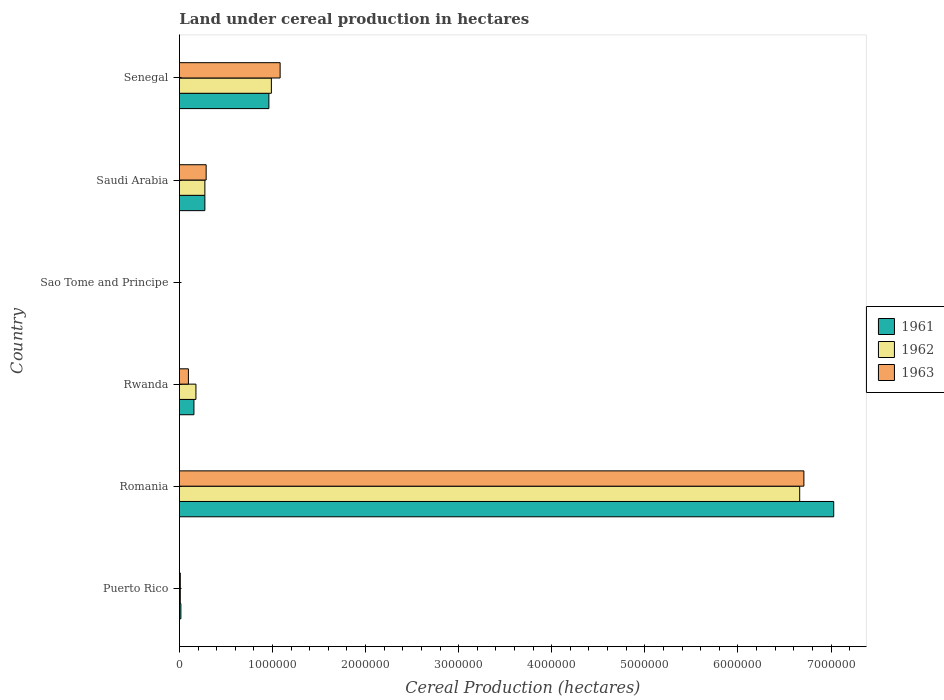How many different coloured bars are there?
Your answer should be very brief. 3. Are the number of bars per tick equal to the number of legend labels?
Your response must be concise. Yes. What is the label of the 4th group of bars from the top?
Your response must be concise. Rwanda. What is the land under cereal production in 1963 in Sao Tome and Principe?
Make the answer very short. 270. Across all countries, what is the maximum land under cereal production in 1963?
Offer a very short reply. 6.71e+06. Across all countries, what is the minimum land under cereal production in 1962?
Give a very brief answer. 270. In which country was the land under cereal production in 1961 maximum?
Your response must be concise. Romania. In which country was the land under cereal production in 1962 minimum?
Make the answer very short. Sao Tome and Principe. What is the total land under cereal production in 1962 in the graph?
Provide a short and direct response. 8.11e+06. What is the difference between the land under cereal production in 1963 in Puerto Rico and that in Romania?
Ensure brevity in your answer.  -6.70e+06. What is the difference between the land under cereal production in 1961 in Saudi Arabia and the land under cereal production in 1963 in Sao Tome and Principe?
Keep it short and to the point. 2.73e+05. What is the average land under cereal production in 1962 per country?
Offer a terse response. 1.35e+06. What is the ratio of the land under cereal production in 1962 in Puerto Rico to that in Senegal?
Make the answer very short. 0.01. Is the land under cereal production in 1962 in Sao Tome and Principe less than that in Senegal?
Provide a short and direct response. Yes. What is the difference between the highest and the second highest land under cereal production in 1963?
Keep it short and to the point. 5.63e+06. What is the difference between the highest and the lowest land under cereal production in 1961?
Give a very brief answer. 7.03e+06. In how many countries, is the land under cereal production in 1963 greater than the average land under cereal production in 1963 taken over all countries?
Offer a very short reply. 1. Is the sum of the land under cereal production in 1963 in Puerto Rico and Sao Tome and Principe greater than the maximum land under cereal production in 1961 across all countries?
Keep it short and to the point. No. What does the 2nd bar from the bottom in Saudi Arabia represents?
Keep it short and to the point. 1962. Is it the case that in every country, the sum of the land under cereal production in 1962 and land under cereal production in 1961 is greater than the land under cereal production in 1963?
Give a very brief answer. Yes. How many bars are there?
Make the answer very short. 18. Are all the bars in the graph horizontal?
Make the answer very short. Yes. Does the graph contain grids?
Keep it short and to the point. No. Where does the legend appear in the graph?
Keep it short and to the point. Center right. How many legend labels are there?
Provide a succinct answer. 3. What is the title of the graph?
Ensure brevity in your answer.  Land under cereal production in hectares. Does "1981" appear as one of the legend labels in the graph?
Your response must be concise. No. What is the label or title of the X-axis?
Offer a very short reply. Cereal Production (hectares). What is the label or title of the Y-axis?
Give a very brief answer. Country. What is the Cereal Production (hectares) in 1961 in Puerto Rico?
Offer a very short reply. 1.59e+04. What is the Cereal Production (hectares) of 1962 in Puerto Rico?
Your answer should be very brief. 9489. What is the Cereal Production (hectares) of 1963 in Puerto Rico?
Offer a terse response. 9519. What is the Cereal Production (hectares) of 1961 in Romania?
Make the answer very short. 7.03e+06. What is the Cereal Production (hectares) in 1962 in Romania?
Offer a very short reply. 6.66e+06. What is the Cereal Production (hectares) of 1963 in Romania?
Provide a short and direct response. 6.71e+06. What is the Cereal Production (hectares) in 1961 in Rwanda?
Your answer should be compact. 1.56e+05. What is the Cereal Production (hectares) in 1962 in Rwanda?
Give a very brief answer. 1.78e+05. What is the Cereal Production (hectares) of 1963 in Rwanda?
Ensure brevity in your answer.  9.66e+04. What is the Cereal Production (hectares) in 1961 in Sao Tome and Principe?
Provide a succinct answer. 270. What is the Cereal Production (hectares) of 1962 in Sao Tome and Principe?
Offer a very short reply. 270. What is the Cereal Production (hectares) in 1963 in Sao Tome and Principe?
Provide a short and direct response. 270. What is the Cereal Production (hectares) of 1961 in Saudi Arabia?
Give a very brief answer. 2.74e+05. What is the Cereal Production (hectares) in 1962 in Saudi Arabia?
Keep it short and to the point. 2.74e+05. What is the Cereal Production (hectares) in 1963 in Saudi Arabia?
Make the answer very short. 2.87e+05. What is the Cereal Production (hectares) of 1961 in Senegal?
Offer a very short reply. 9.61e+05. What is the Cereal Production (hectares) of 1962 in Senegal?
Give a very brief answer. 9.88e+05. What is the Cereal Production (hectares) of 1963 in Senegal?
Make the answer very short. 1.08e+06. Across all countries, what is the maximum Cereal Production (hectares) of 1961?
Offer a terse response. 7.03e+06. Across all countries, what is the maximum Cereal Production (hectares) in 1962?
Give a very brief answer. 6.66e+06. Across all countries, what is the maximum Cereal Production (hectares) of 1963?
Give a very brief answer. 6.71e+06. Across all countries, what is the minimum Cereal Production (hectares) in 1961?
Your answer should be very brief. 270. Across all countries, what is the minimum Cereal Production (hectares) in 1962?
Provide a succinct answer. 270. Across all countries, what is the minimum Cereal Production (hectares) of 1963?
Your response must be concise. 270. What is the total Cereal Production (hectares) in 1961 in the graph?
Your answer should be compact. 8.44e+06. What is the total Cereal Production (hectares) of 1962 in the graph?
Make the answer very short. 8.11e+06. What is the total Cereal Production (hectares) in 1963 in the graph?
Your answer should be compact. 8.18e+06. What is the difference between the Cereal Production (hectares) in 1961 in Puerto Rico and that in Romania?
Offer a terse response. -7.01e+06. What is the difference between the Cereal Production (hectares) in 1962 in Puerto Rico and that in Romania?
Give a very brief answer. -6.65e+06. What is the difference between the Cereal Production (hectares) in 1963 in Puerto Rico and that in Romania?
Give a very brief answer. -6.70e+06. What is the difference between the Cereal Production (hectares) in 1961 in Puerto Rico and that in Rwanda?
Ensure brevity in your answer.  -1.40e+05. What is the difference between the Cereal Production (hectares) of 1962 in Puerto Rico and that in Rwanda?
Make the answer very short. -1.68e+05. What is the difference between the Cereal Production (hectares) of 1963 in Puerto Rico and that in Rwanda?
Give a very brief answer. -8.71e+04. What is the difference between the Cereal Production (hectares) of 1961 in Puerto Rico and that in Sao Tome and Principe?
Keep it short and to the point. 1.56e+04. What is the difference between the Cereal Production (hectares) in 1962 in Puerto Rico and that in Sao Tome and Principe?
Your response must be concise. 9219. What is the difference between the Cereal Production (hectares) in 1963 in Puerto Rico and that in Sao Tome and Principe?
Give a very brief answer. 9249. What is the difference between the Cereal Production (hectares) in 1961 in Puerto Rico and that in Saudi Arabia?
Give a very brief answer. -2.58e+05. What is the difference between the Cereal Production (hectares) in 1962 in Puerto Rico and that in Saudi Arabia?
Give a very brief answer. -2.64e+05. What is the difference between the Cereal Production (hectares) of 1963 in Puerto Rico and that in Saudi Arabia?
Ensure brevity in your answer.  -2.78e+05. What is the difference between the Cereal Production (hectares) of 1961 in Puerto Rico and that in Senegal?
Your response must be concise. -9.45e+05. What is the difference between the Cereal Production (hectares) in 1962 in Puerto Rico and that in Senegal?
Make the answer very short. -9.79e+05. What is the difference between the Cereal Production (hectares) of 1963 in Puerto Rico and that in Senegal?
Your response must be concise. -1.07e+06. What is the difference between the Cereal Production (hectares) of 1961 in Romania and that in Rwanda?
Ensure brevity in your answer.  6.87e+06. What is the difference between the Cereal Production (hectares) of 1962 in Romania and that in Rwanda?
Your answer should be very brief. 6.49e+06. What is the difference between the Cereal Production (hectares) of 1963 in Romania and that in Rwanda?
Your response must be concise. 6.61e+06. What is the difference between the Cereal Production (hectares) of 1961 in Romania and that in Sao Tome and Principe?
Ensure brevity in your answer.  7.03e+06. What is the difference between the Cereal Production (hectares) in 1962 in Romania and that in Sao Tome and Principe?
Your answer should be very brief. 6.66e+06. What is the difference between the Cereal Production (hectares) of 1963 in Romania and that in Sao Tome and Principe?
Provide a short and direct response. 6.71e+06. What is the difference between the Cereal Production (hectares) of 1961 in Romania and that in Saudi Arabia?
Ensure brevity in your answer.  6.76e+06. What is the difference between the Cereal Production (hectares) of 1962 in Romania and that in Saudi Arabia?
Make the answer very short. 6.39e+06. What is the difference between the Cereal Production (hectares) in 1963 in Romania and that in Saudi Arabia?
Provide a short and direct response. 6.42e+06. What is the difference between the Cereal Production (hectares) of 1961 in Romania and that in Senegal?
Your answer should be very brief. 6.07e+06. What is the difference between the Cereal Production (hectares) of 1962 in Romania and that in Senegal?
Your response must be concise. 5.68e+06. What is the difference between the Cereal Production (hectares) of 1963 in Romania and that in Senegal?
Provide a short and direct response. 5.63e+06. What is the difference between the Cereal Production (hectares) of 1961 in Rwanda and that in Sao Tome and Principe?
Your answer should be compact. 1.56e+05. What is the difference between the Cereal Production (hectares) in 1962 in Rwanda and that in Sao Tome and Principe?
Keep it short and to the point. 1.77e+05. What is the difference between the Cereal Production (hectares) of 1963 in Rwanda and that in Sao Tome and Principe?
Offer a very short reply. 9.64e+04. What is the difference between the Cereal Production (hectares) in 1961 in Rwanda and that in Saudi Arabia?
Your response must be concise. -1.17e+05. What is the difference between the Cereal Production (hectares) in 1962 in Rwanda and that in Saudi Arabia?
Your response must be concise. -9.61e+04. What is the difference between the Cereal Production (hectares) in 1963 in Rwanda and that in Saudi Arabia?
Provide a succinct answer. -1.91e+05. What is the difference between the Cereal Production (hectares) of 1961 in Rwanda and that in Senegal?
Provide a succinct answer. -8.05e+05. What is the difference between the Cereal Production (hectares) in 1962 in Rwanda and that in Senegal?
Offer a very short reply. -8.10e+05. What is the difference between the Cereal Production (hectares) of 1963 in Rwanda and that in Senegal?
Keep it short and to the point. -9.85e+05. What is the difference between the Cereal Production (hectares) of 1961 in Sao Tome and Principe and that in Saudi Arabia?
Your answer should be very brief. -2.73e+05. What is the difference between the Cereal Production (hectares) of 1962 in Sao Tome and Principe and that in Saudi Arabia?
Make the answer very short. -2.73e+05. What is the difference between the Cereal Production (hectares) in 1963 in Sao Tome and Principe and that in Saudi Arabia?
Ensure brevity in your answer.  -2.87e+05. What is the difference between the Cereal Production (hectares) in 1961 in Sao Tome and Principe and that in Senegal?
Offer a very short reply. -9.61e+05. What is the difference between the Cereal Production (hectares) in 1962 in Sao Tome and Principe and that in Senegal?
Offer a terse response. -9.88e+05. What is the difference between the Cereal Production (hectares) in 1963 in Sao Tome and Principe and that in Senegal?
Ensure brevity in your answer.  -1.08e+06. What is the difference between the Cereal Production (hectares) of 1961 in Saudi Arabia and that in Senegal?
Provide a succinct answer. -6.88e+05. What is the difference between the Cereal Production (hectares) of 1962 in Saudi Arabia and that in Senegal?
Keep it short and to the point. -7.14e+05. What is the difference between the Cereal Production (hectares) in 1963 in Saudi Arabia and that in Senegal?
Offer a terse response. -7.95e+05. What is the difference between the Cereal Production (hectares) in 1961 in Puerto Rico and the Cereal Production (hectares) in 1962 in Romania?
Ensure brevity in your answer.  -6.65e+06. What is the difference between the Cereal Production (hectares) of 1961 in Puerto Rico and the Cereal Production (hectares) of 1963 in Romania?
Give a very brief answer. -6.69e+06. What is the difference between the Cereal Production (hectares) in 1962 in Puerto Rico and the Cereal Production (hectares) in 1963 in Romania?
Ensure brevity in your answer.  -6.70e+06. What is the difference between the Cereal Production (hectares) of 1961 in Puerto Rico and the Cereal Production (hectares) of 1962 in Rwanda?
Ensure brevity in your answer.  -1.62e+05. What is the difference between the Cereal Production (hectares) in 1961 in Puerto Rico and the Cereal Production (hectares) in 1963 in Rwanda?
Keep it short and to the point. -8.08e+04. What is the difference between the Cereal Production (hectares) of 1962 in Puerto Rico and the Cereal Production (hectares) of 1963 in Rwanda?
Ensure brevity in your answer.  -8.72e+04. What is the difference between the Cereal Production (hectares) in 1961 in Puerto Rico and the Cereal Production (hectares) in 1962 in Sao Tome and Principe?
Offer a very short reply. 1.56e+04. What is the difference between the Cereal Production (hectares) in 1961 in Puerto Rico and the Cereal Production (hectares) in 1963 in Sao Tome and Principe?
Offer a terse response. 1.56e+04. What is the difference between the Cereal Production (hectares) of 1962 in Puerto Rico and the Cereal Production (hectares) of 1963 in Sao Tome and Principe?
Your response must be concise. 9219. What is the difference between the Cereal Production (hectares) in 1961 in Puerto Rico and the Cereal Production (hectares) in 1962 in Saudi Arabia?
Ensure brevity in your answer.  -2.58e+05. What is the difference between the Cereal Production (hectares) in 1961 in Puerto Rico and the Cereal Production (hectares) in 1963 in Saudi Arabia?
Give a very brief answer. -2.71e+05. What is the difference between the Cereal Production (hectares) in 1962 in Puerto Rico and the Cereal Production (hectares) in 1963 in Saudi Arabia?
Provide a short and direct response. -2.78e+05. What is the difference between the Cereal Production (hectares) in 1961 in Puerto Rico and the Cereal Production (hectares) in 1962 in Senegal?
Offer a terse response. -9.72e+05. What is the difference between the Cereal Production (hectares) in 1961 in Puerto Rico and the Cereal Production (hectares) in 1963 in Senegal?
Provide a short and direct response. -1.07e+06. What is the difference between the Cereal Production (hectares) of 1962 in Puerto Rico and the Cereal Production (hectares) of 1963 in Senegal?
Your answer should be very brief. -1.07e+06. What is the difference between the Cereal Production (hectares) of 1961 in Romania and the Cereal Production (hectares) of 1962 in Rwanda?
Provide a succinct answer. 6.85e+06. What is the difference between the Cereal Production (hectares) in 1961 in Romania and the Cereal Production (hectares) in 1963 in Rwanda?
Ensure brevity in your answer.  6.93e+06. What is the difference between the Cereal Production (hectares) in 1962 in Romania and the Cereal Production (hectares) in 1963 in Rwanda?
Your response must be concise. 6.57e+06. What is the difference between the Cereal Production (hectares) in 1961 in Romania and the Cereal Production (hectares) in 1962 in Sao Tome and Principe?
Ensure brevity in your answer.  7.03e+06. What is the difference between the Cereal Production (hectares) in 1961 in Romania and the Cereal Production (hectares) in 1963 in Sao Tome and Principe?
Give a very brief answer. 7.03e+06. What is the difference between the Cereal Production (hectares) of 1962 in Romania and the Cereal Production (hectares) of 1963 in Sao Tome and Principe?
Make the answer very short. 6.66e+06. What is the difference between the Cereal Production (hectares) in 1961 in Romania and the Cereal Production (hectares) in 1962 in Saudi Arabia?
Ensure brevity in your answer.  6.76e+06. What is the difference between the Cereal Production (hectares) of 1961 in Romania and the Cereal Production (hectares) of 1963 in Saudi Arabia?
Offer a very short reply. 6.74e+06. What is the difference between the Cereal Production (hectares) in 1962 in Romania and the Cereal Production (hectares) in 1963 in Saudi Arabia?
Provide a succinct answer. 6.38e+06. What is the difference between the Cereal Production (hectares) of 1961 in Romania and the Cereal Production (hectares) of 1962 in Senegal?
Provide a succinct answer. 6.04e+06. What is the difference between the Cereal Production (hectares) in 1961 in Romania and the Cereal Production (hectares) in 1963 in Senegal?
Your answer should be very brief. 5.95e+06. What is the difference between the Cereal Production (hectares) in 1962 in Romania and the Cereal Production (hectares) in 1963 in Senegal?
Provide a succinct answer. 5.58e+06. What is the difference between the Cereal Production (hectares) of 1961 in Rwanda and the Cereal Production (hectares) of 1962 in Sao Tome and Principe?
Ensure brevity in your answer.  1.56e+05. What is the difference between the Cereal Production (hectares) of 1961 in Rwanda and the Cereal Production (hectares) of 1963 in Sao Tome and Principe?
Give a very brief answer. 1.56e+05. What is the difference between the Cereal Production (hectares) of 1962 in Rwanda and the Cereal Production (hectares) of 1963 in Sao Tome and Principe?
Keep it short and to the point. 1.77e+05. What is the difference between the Cereal Production (hectares) in 1961 in Rwanda and the Cereal Production (hectares) in 1962 in Saudi Arabia?
Your answer should be compact. -1.18e+05. What is the difference between the Cereal Production (hectares) of 1961 in Rwanda and the Cereal Production (hectares) of 1963 in Saudi Arabia?
Keep it short and to the point. -1.31e+05. What is the difference between the Cereal Production (hectares) of 1962 in Rwanda and the Cereal Production (hectares) of 1963 in Saudi Arabia?
Keep it short and to the point. -1.10e+05. What is the difference between the Cereal Production (hectares) in 1961 in Rwanda and the Cereal Production (hectares) in 1962 in Senegal?
Give a very brief answer. -8.32e+05. What is the difference between the Cereal Production (hectares) in 1961 in Rwanda and the Cereal Production (hectares) in 1963 in Senegal?
Offer a very short reply. -9.26e+05. What is the difference between the Cereal Production (hectares) of 1962 in Rwanda and the Cereal Production (hectares) of 1963 in Senegal?
Offer a very short reply. -9.04e+05. What is the difference between the Cereal Production (hectares) of 1961 in Sao Tome and Principe and the Cereal Production (hectares) of 1962 in Saudi Arabia?
Your answer should be very brief. -2.73e+05. What is the difference between the Cereal Production (hectares) of 1961 in Sao Tome and Principe and the Cereal Production (hectares) of 1963 in Saudi Arabia?
Give a very brief answer. -2.87e+05. What is the difference between the Cereal Production (hectares) in 1962 in Sao Tome and Principe and the Cereal Production (hectares) in 1963 in Saudi Arabia?
Give a very brief answer. -2.87e+05. What is the difference between the Cereal Production (hectares) in 1961 in Sao Tome and Principe and the Cereal Production (hectares) in 1962 in Senegal?
Make the answer very short. -9.88e+05. What is the difference between the Cereal Production (hectares) in 1961 in Sao Tome and Principe and the Cereal Production (hectares) in 1963 in Senegal?
Your answer should be compact. -1.08e+06. What is the difference between the Cereal Production (hectares) of 1962 in Sao Tome and Principe and the Cereal Production (hectares) of 1963 in Senegal?
Your answer should be very brief. -1.08e+06. What is the difference between the Cereal Production (hectares) in 1961 in Saudi Arabia and the Cereal Production (hectares) in 1962 in Senegal?
Your response must be concise. -7.14e+05. What is the difference between the Cereal Production (hectares) of 1961 in Saudi Arabia and the Cereal Production (hectares) of 1963 in Senegal?
Keep it short and to the point. -8.08e+05. What is the difference between the Cereal Production (hectares) in 1962 in Saudi Arabia and the Cereal Production (hectares) in 1963 in Senegal?
Provide a succinct answer. -8.08e+05. What is the average Cereal Production (hectares) of 1961 per country?
Give a very brief answer. 1.41e+06. What is the average Cereal Production (hectares) in 1962 per country?
Provide a short and direct response. 1.35e+06. What is the average Cereal Production (hectares) of 1963 per country?
Provide a short and direct response. 1.36e+06. What is the difference between the Cereal Production (hectares) of 1961 and Cereal Production (hectares) of 1962 in Puerto Rico?
Provide a short and direct response. 6383. What is the difference between the Cereal Production (hectares) in 1961 and Cereal Production (hectares) in 1963 in Puerto Rico?
Provide a succinct answer. 6353. What is the difference between the Cereal Production (hectares) in 1961 and Cereal Production (hectares) in 1962 in Romania?
Provide a short and direct response. 3.65e+05. What is the difference between the Cereal Production (hectares) in 1961 and Cereal Production (hectares) in 1963 in Romania?
Give a very brief answer. 3.20e+05. What is the difference between the Cereal Production (hectares) in 1962 and Cereal Production (hectares) in 1963 in Romania?
Make the answer very short. -4.51e+04. What is the difference between the Cereal Production (hectares) of 1961 and Cereal Production (hectares) of 1962 in Rwanda?
Ensure brevity in your answer.  -2.15e+04. What is the difference between the Cereal Production (hectares) of 1961 and Cereal Production (hectares) of 1963 in Rwanda?
Ensure brevity in your answer.  5.94e+04. What is the difference between the Cereal Production (hectares) in 1962 and Cereal Production (hectares) in 1963 in Rwanda?
Provide a short and direct response. 8.09e+04. What is the difference between the Cereal Production (hectares) in 1961 and Cereal Production (hectares) in 1962 in Sao Tome and Principe?
Your answer should be compact. 0. What is the difference between the Cereal Production (hectares) in 1961 and Cereal Production (hectares) in 1963 in Sao Tome and Principe?
Your answer should be very brief. 0. What is the difference between the Cereal Production (hectares) in 1962 and Cereal Production (hectares) in 1963 in Sao Tome and Principe?
Your response must be concise. 0. What is the difference between the Cereal Production (hectares) of 1961 and Cereal Production (hectares) of 1962 in Saudi Arabia?
Provide a succinct answer. -100. What is the difference between the Cereal Production (hectares) of 1961 and Cereal Production (hectares) of 1963 in Saudi Arabia?
Ensure brevity in your answer.  -1.38e+04. What is the difference between the Cereal Production (hectares) of 1962 and Cereal Production (hectares) of 1963 in Saudi Arabia?
Your answer should be very brief. -1.37e+04. What is the difference between the Cereal Production (hectares) in 1961 and Cereal Production (hectares) in 1962 in Senegal?
Your response must be concise. -2.68e+04. What is the difference between the Cereal Production (hectares) of 1961 and Cereal Production (hectares) of 1963 in Senegal?
Offer a very short reply. -1.21e+05. What is the difference between the Cereal Production (hectares) in 1962 and Cereal Production (hectares) in 1963 in Senegal?
Your response must be concise. -9.40e+04. What is the ratio of the Cereal Production (hectares) of 1961 in Puerto Rico to that in Romania?
Give a very brief answer. 0. What is the ratio of the Cereal Production (hectares) of 1962 in Puerto Rico to that in Romania?
Your answer should be very brief. 0. What is the ratio of the Cereal Production (hectares) of 1963 in Puerto Rico to that in Romania?
Your response must be concise. 0. What is the ratio of the Cereal Production (hectares) in 1961 in Puerto Rico to that in Rwanda?
Offer a very short reply. 0.1. What is the ratio of the Cereal Production (hectares) of 1962 in Puerto Rico to that in Rwanda?
Make the answer very short. 0.05. What is the ratio of the Cereal Production (hectares) in 1963 in Puerto Rico to that in Rwanda?
Offer a very short reply. 0.1. What is the ratio of the Cereal Production (hectares) in 1961 in Puerto Rico to that in Sao Tome and Principe?
Your response must be concise. 58.79. What is the ratio of the Cereal Production (hectares) of 1962 in Puerto Rico to that in Sao Tome and Principe?
Make the answer very short. 35.14. What is the ratio of the Cereal Production (hectares) of 1963 in Puerto Rico to that in Sao Tome and Principe?
Your answer should be compact. 35.26. What is the ratio of the Cereal Production (hectares) of 1961 in Puerto Rico to that in Saudi Arabia?
Give a very brief answer. 0.06. What is the ratio of the Cereal Production (hectares) of 1962 in Puerto Rico to that in Saudi Arabia?
Your answer should be compact. 0.03. What is the ratio of the Cereal Production (hectares) in 1963 in Puerto Rico to that in Saudi Arabia?
Give a very brief answer. 0.03. What is the ratio of the Cereal Production (hectares) of 1961 in Puerto Rico to that in Senegal?
Ensure brevity in your answer.  0.02. What is the ratio of the Cereal Production (hectares) in 1962 in Puerto Rico to that in Senegal?
Provide a short and direct response. 0.01. What is the ratio of the Cereal Production (hectares) in 1963 in Puerto Rico to that in Senegal?
Offer a terse response. 0.01. What is the ratio of the Cereal Production (hectares) of 1961 in Romania to that in Rwanda?
Provide a succinct answer. 45.04. What is the ratio of the Cereal Production (hectares) of 1962 in Romania to that in Rwanda?
Your answer should be compact. 37.53. What is the ratio of the Cereal Production (hectares) in 1963 in Romania to that in Rwanda?
Provide a short and direct response. 69.42. What is the ratio of the Cereal Production (hectares) of 1961 in Romania to that in Sao Tome and Principe?
Your response must be concise. 2.60e+04. What is the ratio of the Cereal Production (hectares) in 1962 in Romania to that in Sao Tome and Principe?
Make the answer very short. 2.47e+04. What is the ratio of the Cereal Production (hectares) of 1963 in Romania to that in Sao Tome and Principe?
Your answer should be very brief. 2.48e+04. What is the ratio of the Cereal Production (hectares) in 1961 in Romania to that in Saudi Arabia?
Ensure brevity in your answer.  25.7. What is the ratio of the Cereal Production (hectares) in 1962 in Romania to that in Saudi Arabia?
Provide a short and direct response. 24.36. What is the ratio of the Cereal Production (hectares) of 1963 in Romania to that in Saudi Arabia?
Give a very brief answer. 23.35. What is the ratio of the Cereal Production (hectares) in 1961 in Romania to that in Senegal?
Offer a terse response. 7.31. What is the ratio of the Cereal Production (hectares) of 1962 in Romania to that in Senegal?
Keep it short and to the point. 6.74. What is the ratio of the Cereal Production (hectares) of 1963 in Romania to that in Senegal?
Your answer should be very brief. 6.2. What is the ratio of the Cereal Production (hectares) in 1961 in Rwanda to that in Sao Tome and Principe?
Your answer should be very brief. 578.07. What is the ratio of the Cereal Production (hectares) of 1962 in Rwanda to that in Sao Tome and Principe?
Offer a very short reply. 657.55. What is the ratio of the Cereal Production (hectares) of 1963 in Rwanda to that in Sao Tome and Principe?
Keep it short and to the point. 357.94. What is the ratio of the Cereal Production (hectares) of 1961 in Rwanda to that in Saudi Arabia?
Ensure brevity in your answer.  0.57. What is the ratio of the Cereal Production (hectares) in 1962 in Rwanda to that in Saudi Arabia?
Provide a short and direct response. 0.65. What is the ratio of the Cereal Production (hectares) in 1963 in Rwanda to that in Saudi Arabia?
Make the answer very short. 0.34. What is the ratio of the Cereal Production (hectares) in 1961 in Rwanda to that in Senegal?
Make the answer very short. 0.16. What is the ratio of the Cereal Production (hectares) of 1962 in Rwanda to that in Senegal?
Offer a very short reply. 0.18. What is the ratio of the Cereal Production (hectares) of 1963 in Rwanda to that in Senegal?
Your response must be concise. 0.09. What is the ratio of the Cereal Production (hectares) of 1961 in Sao Tome and Principe to that in Saudi Arabia?
Provide a succinct answer. 0. What is the ratio of the Cereal Production (hectares) of 1962 in Sao Tome and Principe to that in Saudi Arabia?
Your answer should be compact. 0. What is the ratio of the Cereal Production (hectares) of 1963 in Sao Tome and Principe to that in Saudi Arabia?
Offer a terse response. 0. What is the ratio of the Cereal Production (hectares) of 1961 in Sao Tome and Principe to that in Senegal?
Offer a very short reply. 0. What is the ratio of the Cereal Production (hectares) in 1961 in Saudi Arabia to that in Senegal?
Offer a very short reply. 0.28. What is the ratio of the Cereal Production (hectares) of 1962 in Saudi Arabia to that in Senegal?
Keep it short and to the point. 0.28. What is the ratio of the Cereal Production (hectares) in 1963 in Saudi Arabia to that in Senegal?
Keep it short and to the point. 0.27. What is the difference between the highest and the second highest Cereal Production (hectares) in 1961?
Make the answer very short. 6.07e+06. What is the difference between the highest and the second highest Cereal Production (hectares) in 1962?
Your answer should be compact. 5.68e+06. What is the difference between the highest and the second highest Cereal Production (hectares) of 1963?
Your answer should be compact. 5.63e+06. What is the difference between the highest and the lowest Cereal Production (hectares) in 1961?
Your answer should be very brief. 7.03e+06. What is the difference between the highest and the lowest Cereal Production (hectares) in 1962?
Your answer should be very brief. 6.66e+06. What is the difference between the highest and the lowest Cereal Production (hectares) in 1963?
Keep it short and to the point. 6.71e+06. 